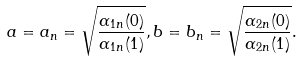Convert formula to latex. <formula><loc_0><loc_0><loc_500><loc_500>a = a _ { n } = \sqrt { \frac { \alpha _ { 1 n } ( 0 ) } { \alpha _ { 1 n } ( 1 ) } } , b = b _ { n } = \sqrt { \frac { \alpha _ { 2 n } ( 0 ) } { \alpha _ { 2 n } ( 1 ) } } .</formula> 